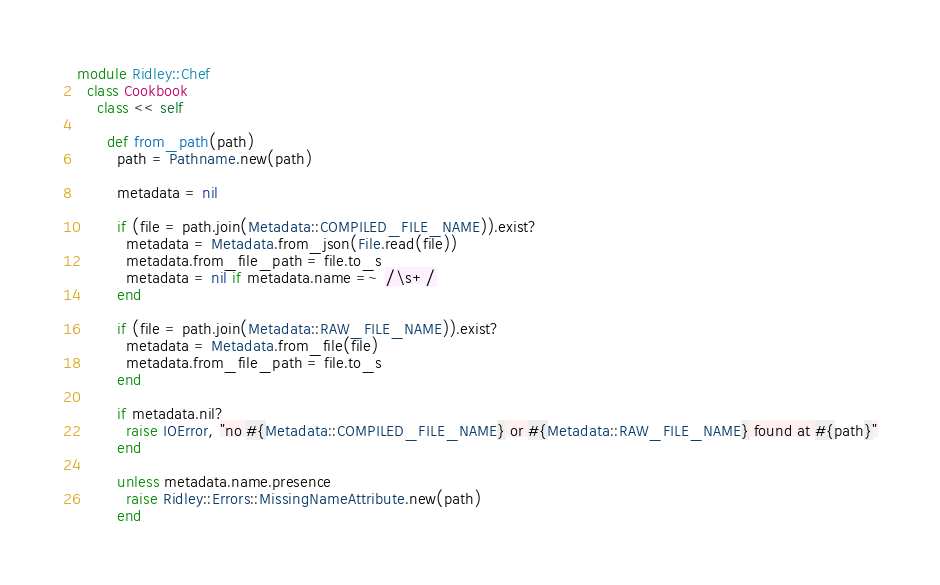<code> <loc_0><loc_0><loc_500><loc_500><_Ruby_>
module Ridley::Chef
  class Cookbook
    class << self

      def from_path(path)
        path = Pathname.new(path)

        metadata = nil

        if (file = path.join(Metadata::COMPILED_FILE_NAME)).exist?
          metadata = Metadata.from_json(File.read(file))
          metadata.from_file_path = file.to_s
          metadata = nil if metadata.name =~ /\s+/
        end
        
        if (file = path.join(Metadata::RAW_FILE_NAME)).exist?
          metadata = Metadata.from_file(file)
          metadata.from_file_path = file.to_s
        end

        if metadata.nil?
          raise IOError, "no #{Metadata::COMPILED_FILE_NAME} or #{Metadata::RAW_FILE_NAME} found at #{path}"
        end

        unless metadata.name.presence
          raise Ridley::Errors::MissingNameAttribute.new(path)
        end
</code> 